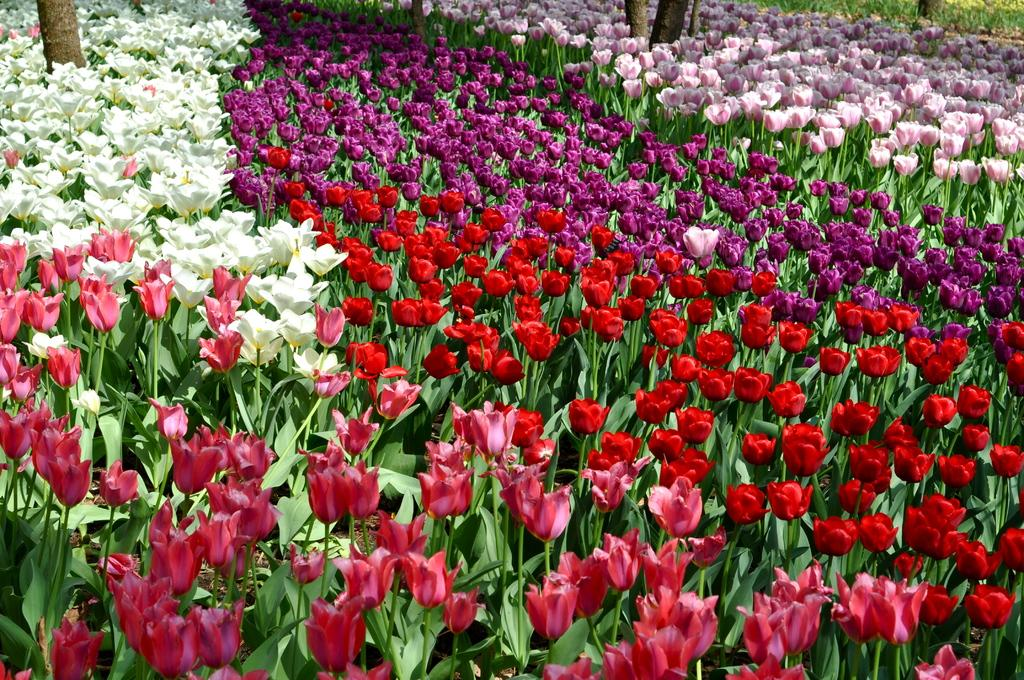What is the main subject of the image? The main subject of the image is plants. Where are the plants located in the image? The plants are in the center of the image. What additional feature can be observed on the plants? The plants have flowers. What can be said about the appearance of the flowers? The flowers are in different colors. What type of zephyr can be seen blowing through the flowers in the image? There is no zephyr present in the image; it is a still image of plants with flowers. 